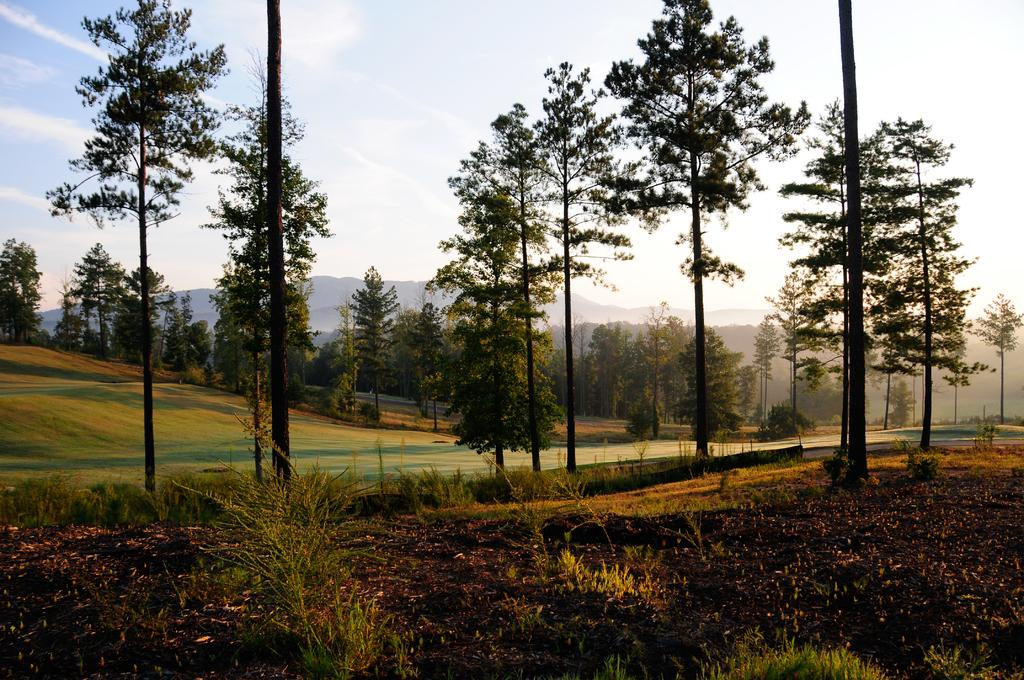What type of vegetation can be seen in the image? There are plants and trees visible in the image. What part of the trees can be seen in the image? The bark of trees is visible in the image. What type of ground cover is present in the image? There is grass in the image. How many trees are grouped together in the image? There is a group of trees in the image. What can be seen in the distance in the image? Hills are visible in the background of the image. How would you describe the sky in the image? The sky is visible in the image and appears cloudy. What type of leather is being used to protect the throat of the person in the image? There is no person or leather visible in the image; it features plants, trees, grass, hills, and a cloudy sky. 